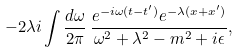Convert formula to latex. <formula><loc_0><loc_0><loc_500><loc_500>- 2 \lambda i \int \frac { d \omega } { 2 \pi } \, \frac { e ^ { - i \omega ( t - t ^ { \prime } ) } e ^ { - \lambda ( x + x ^ { \prime } ) } } { \omega ^ { 2 } + \lambda ^ { 2 } - m ^ { 2 } + i \epsilon } ,</formula> 